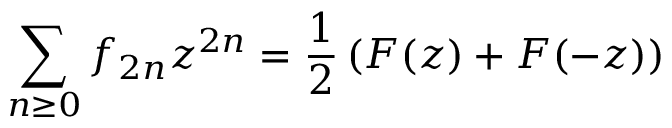<formula> <loc_0><loc_0><loc_500><loc_500>\sum _ { n \geq 0 } f _ { 2 n } z ^ { 2 n } = { \frac { 1 } { 2 } } \left ( F ( z ) + F ( - z ) \right )</formula> 